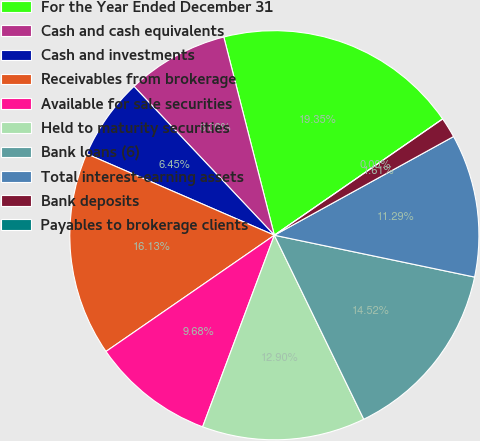Convert chart. <chart><loc_0><loc_0><loc_500><loc_500><pie_chart><fcel>For the Year Ended December 31<fcel>Cash and cash equivalents<fcel>Cash and investments<fcel>Receivables from brokerage<fcel>Available for sale securities<fcel>Held to maturity securities<fcel>Bank loans (6)<fcel>Total interest-earning assets<fcel>Bank deposits<fcel>Payables to brokerage clients<nl><fcel>19.35%<fcel>8.06%<fcel>6.45%<fcel>16.13%<fcel>9.68%<fcel>12.9%<fcel>14.52%<fcel>11.29%<fcel>1.61%<fcel>0.0%<nl></chart> 